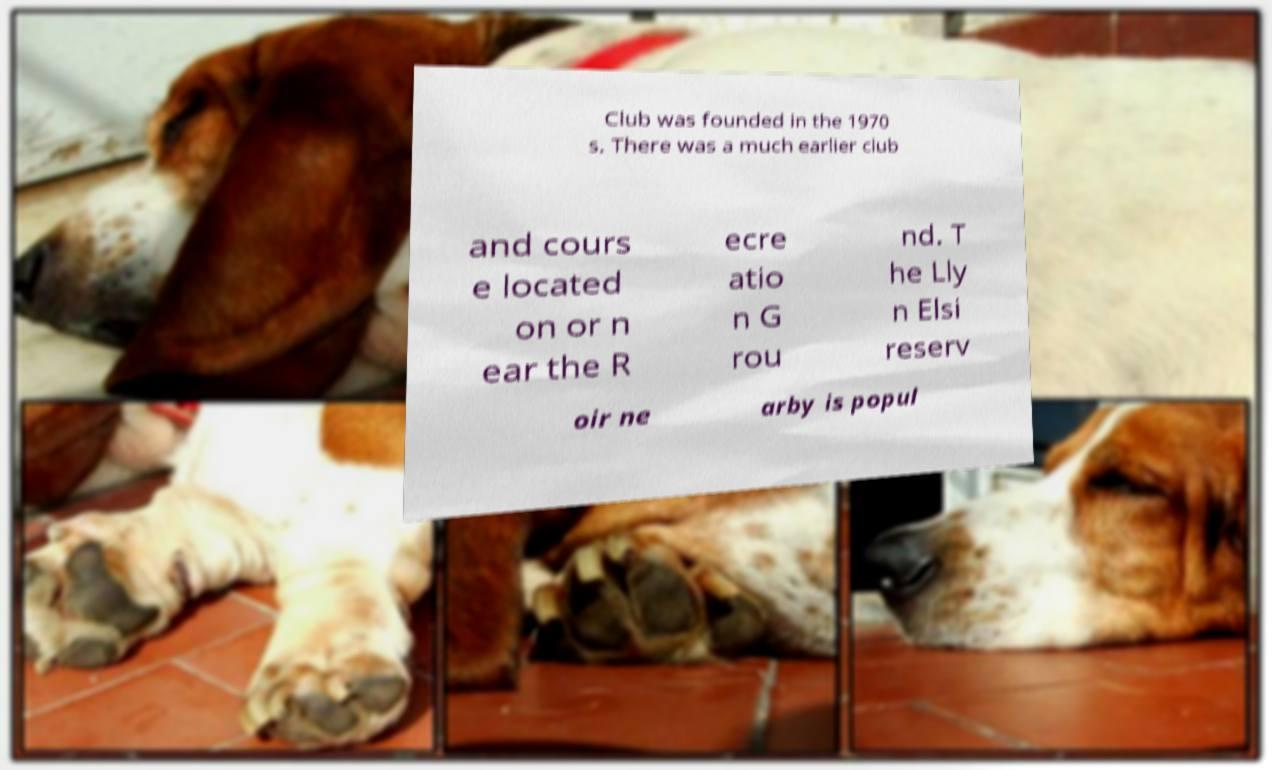Please read and relay the text visible in this image. What does it say? Club was founded in the 1970 s. There was a much earlier club and cours e located on or n ear the R ecre atio n G rou nd. T he Lly n Elsi reserv oir ne arby is popul 